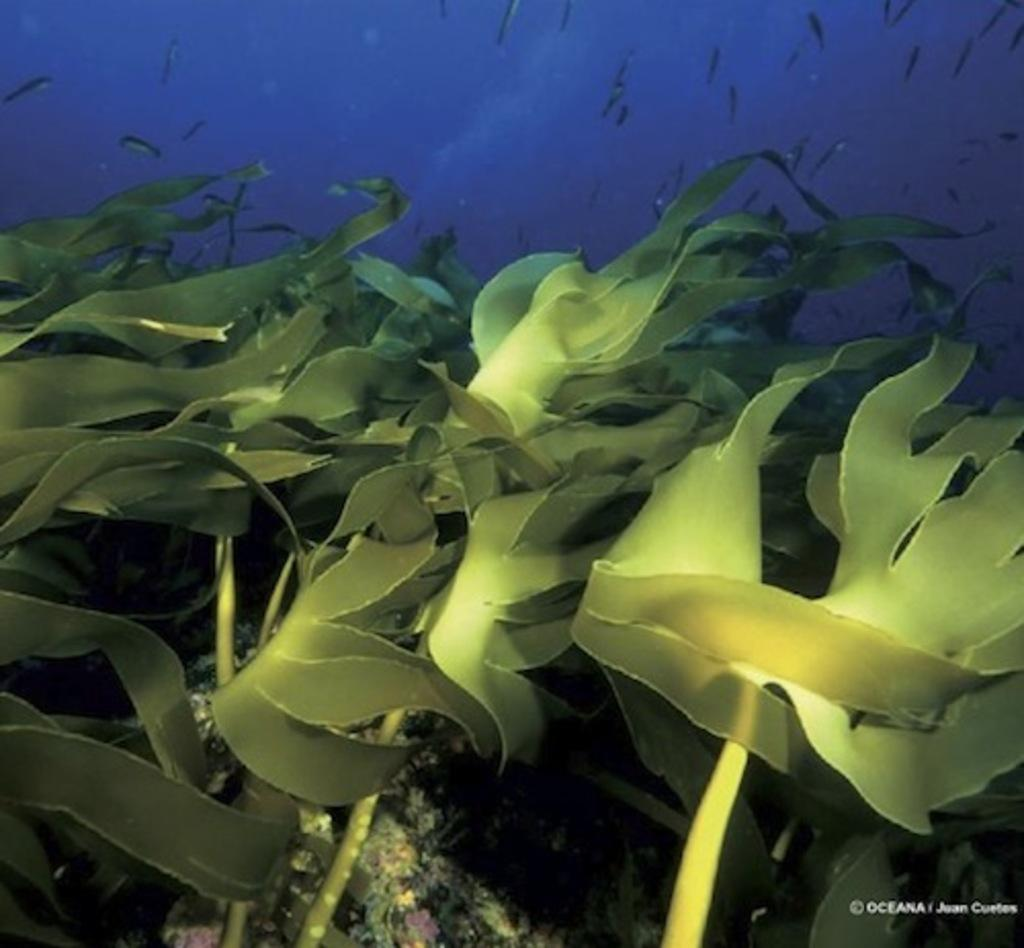What type of environment is shown in the image? The image depicts an underwater environment. What can be found within the water in the image? There are plants in the water. What other living organisms can be seen in the image? Water animals are visible at the top of the image. What type of collar can be seen on the fish in the image? There are no collars present on the fish in the image, as fish do not wear collars. 